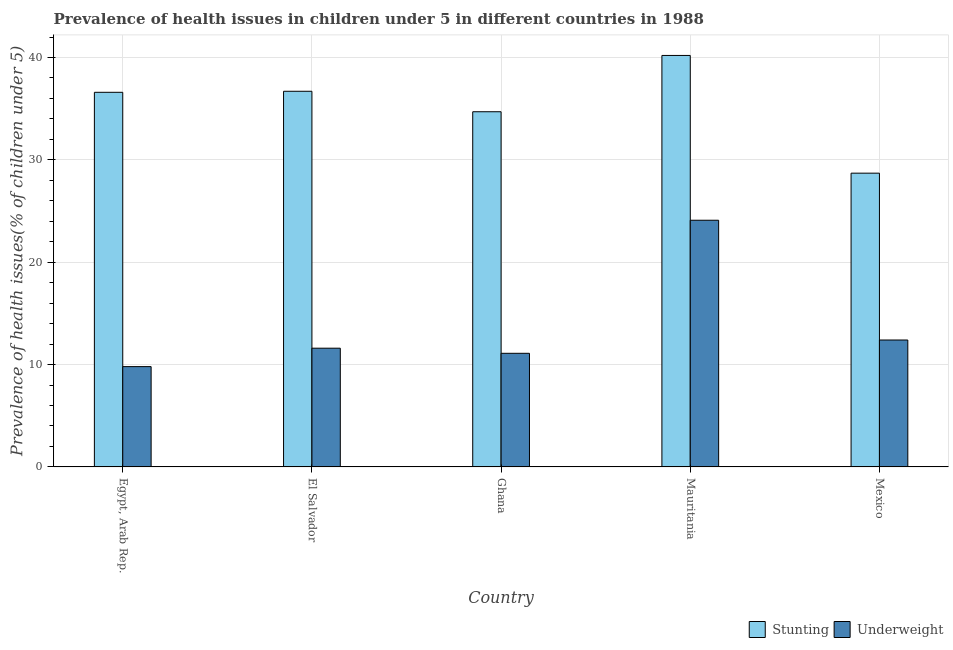How many different coloured bars are there?
Your answer should be very brief. 2. How many groups of bars are there?
Your answer should be very brief. 5. How many bars are there on the 1st tick from the right?
Offer a very short reply. 2. What is the percentage of stunted children in Mexico?
Keep it short and to the point. 28.7. Across all countries, what is the maximum percentage of underweight children?
Offer a terse response. 24.1. Across all countries, what is the minimum percentage of stunted children?
Make the answer very short. 28.7. In which country was the percentage of stunted children maximum?
Ensure brevity in your answer.  Mauritania. What is the total percentage of underweight children in the graph?
Your answer should be very brief. 69. What is the difference between the percentage of stunted children in El Salvador and that in Mauritania?
Your answer should be compact. -3.5. What is the difference between the percentage of underweight children in Mexico and the percentage of stunted children in Ghana?
Ensure brevity in your answer.  -22.3. What is the average percentage of underweight children per country?
Provide a succinct answer. 13.8. What is the difference between the percentage of underweight children and percentage of stunted children in Mexico?
Provide a succinct answer. -16.3. In how many countries, is the percentage of underweight children greater than 40 %?
Your answer should be very brief. 0. What is the ratio of the percentage of stunted children in Ghana to that in Mauritania?
Provide a succinct answer. 0.86. Is the difference between the percentage of stunted children in El Salvador and Ghana greater than the difference between the percentage of underweight children in El Salvador and Ghana?
Make the answer very short. Yes. What is the difference between the highest and the second highest percentage of stunted children?
Offer a terse response. 3.5. What is the difference between the highest and the lowest percentage of underweight children?
Your answer should be very brief. 14.3. In how many countries, is the percentage of underweight children greater than the average percentage of underweight children taken over all countries?
Make the answer very short. 1. Is the sum of the percentage of stunted children in Egypt, Arab Rep. and El Salvador greater than the maximum percentage of underweight children across all countries?
Offer a very short reply. Yes. What does the 2nd bar from the left in Egypt, Arab Rep. represents?
Offer a terse response. Underweight. What does the 2nd bar from the right in Ghana represents?
Your response must be concise. Stunting. How many bars are there?
Ensure brevity in your answer.  10. How many countries are there in the graph?
Give a very brief answer. 5. Are the values on the major ticks of Y-axis written in scientific E-notation?
Provide a short and direct response. No. Does the graph contain grids?
Provide a succinct answer. Yes. Where does the legend appear in the graph?
Ensure brevity in your answer.  Bottom right. How many legend labels are there?
Ensure brevity in your answer.  2. How are the legend labels stacked?
Provide a short and direct response. Horizontal. What is the title of the graph?
Offer a very short reply. Prevalence of health issues in children under 5 in different countries in 1988. What is the label or title of the Y-axis?
Provide a succinct answer. Prevalence of health issues(% of children under 5). What is the Prevalence of health issues(% of children under 5) in Stunting in Egypt, Arab Rep.?
Your answer should be very brief. 36.6. What is the Prevalence of health issues(% of children under 5) in Underweight in Egypt, Arab Rep.?
Offer a terse response. 9.8. What is the Prevalence of health issues(% of children under 5) of Stunting in El Salvador?
Your answer should be compact. 36.7. What is the Prevalence of health issues(% of children under 5) in Underweight in El Salvador?
Keep it short and to the point. 11.6. What is the Prevalence of health issues(% of children under 5) in Stunting in Ghana?
Offer a terse response. 34.7. What is the Prevalence of health issues(% of children under 5) in Underweight in Ghana?
Your response must be concise. 11.1. What is the Prevalence of health issues(% of children under 5) in Stunting in Mauritania?
Offer a terse response. 40.2. What is the Prevalence of health issues(% of children under 5) of Underweight in Mauritania?
Offer a terse response. 24.1. What is the Prevalence of health issues(% of children under 5) in Stunting in Mexico?
Offer a terse response. 28.7. What is the Prevalence of health issues(% of children under 5) in Underweight in Mexico?
Ensure brevity in your answer.  12.4. Across all countries, what is the maximum Prevalence of health issues(% of children under 5) of Stunting?
Give a very brief answer. 40.2. Across all countries, what is the maximum Prevalence of health issues(% of children under 5) of Underweight?
Ensure brevity in your answer.  24.1. Across all countries, what is the minimum Prevalence of health issues(% of children under 5) of Stunting?
Offer a terse response. 28.7. Across all countries, what is the minimum Prevalence of health issues(% of children under 5) in Underweight?
Give a very brief answer. 9.8. What is the total Prevalence of health issues(% of children under 5) in Stunting in the graph?
Keep it short and to the point. 176.9. What is the difference between the Prevalence of health issues(% of children under 5) of Underweight in Egypt, Arab Rep. and that in El Salvador?
Give a very brief answer. -1.8. What is the difference between the Prevalence of health issues(% of children under 5) in Stunting in Egypt, Arab Rep. and that in Ghana?
Your response must be concise. 1.9. What is the difference between the Prevalence of health issues(% of children under 5) in Underweight in Egypt, Arab Rep. and that in Ghana?
Provide a succinct answer. -1.3. What is the difference between the Prevalence of health issues(% of children under 5) of Stunting in Egypt, Arab Rep. and that in Mauritania?
Give a very brief answer. -3.6. What is the difference between the Prevalence of health issues(% of children under 5) of Underweight in Egypt, Arab Rep. and that in Mauritania?
Your answer should be very brief. -14.3. What is the difference between the Prevalence of health issues(% of children under 5) of Underweight in Egypt, Arab Rep. and that in Mexico?
Ensure brevity in your answer.  -2.6. What is the difference between the Prevalence of health issues(% of children under 5) in Underweight in El Salvador and that in Ghana?
Your answer should be very brief. 0.5. What is the difference between the Prevalence of health issues(% of children under 5) in Stunting in El Salvador and that in Mexico?
Ensure brevity in your answer.  8. What is the difference between the Prevalence of health issues(% of children under 5) of Stunting in Ghana and that in Mauritania?
Your answer should be very brief. -5.5. What is the difference between the Prevalence of health issues(% of children under 5) of Stunting in Ghana and that in Mexico?
Give a very brief answer. 6. What is the difference between the Prevalence of health issues(% of children under 5) in Stunting in Egypt, Arab Rep. and the Prevalence of health issues(% of children under 5) in Underweight in El Salvador?
Give a very brief answer. 25. What is the difference between the Prevalence of health issues(% of children under 5) of Stunting in Egypt, Arab Rep. and the Prevalence of health issues(% of children under 5) of Underweight in Ghana?
Provide a succinct answer. 25.5. What is the difference between the Prevalence of health issues(% of children under 5) in Stunting in Egypt, Arab Rep. and the Prevalence of health issues(% of children under 5) in Underweight in Mauritania?
Offer a terse response. 12.5. What is the difference between the Prevalence of health issues(% of children under 5) of Stunting in Egypt, Arab Rep. and the Prevalence of health issues(% of children under 5) of Underweight in Mexico?
Offer a very short reply. 24.2. What is the difference between the Prevalence of health issues(% of children under 5) of Stunting in El Salvador and the Prevalence of health issues(% of children under 5) of Underweight in Ghana?
Provide a succinct answer. 25.6. What is the difference between the Prevalence of health issues(% of children under 5) of Stunting in El Salvador and the Prevalence of health issues(% of children under 5) of Underweight in Mauritania?
Provide a short and direct response. 12.6. What is the difference between the Prevalence of health issues(% of children under 5) of Stunting in El Salvador and the Prevalence of health issues(% of children under 5) of Underweight in Mexico?
Offer a very short reply. 24.3. What is the difference between the Prevalence of health issues(% of children under 5) of Stunting in Ghana and the Prevalence of health issues(% of children under 5) of Underweight in Mauritania?
Offer a very short reply. 10.6. What is the difference between the Prevalence of health issues(% of children under 5) in Stunting in Ghana and the Prevalence of health issues(% of children under 5) in Underweight in Mexico?
Offer a terse response. 22.3. What is the difference between the Prevalence of health issues(% of children under 5) in Stunting in Mauritania and the Prevalence of health issues(% of children under 5) in Underweight in Mexico?
Give a very brief answer. 27.8. What is the average Prevalence of health issues(% of children under 5) in Stunting per country?
Give a very brief answer. 35.38. What is the average Prevalence of health issues(% of children under 5) in Underweight per country?
Provide a short and direct response. 13.8. What is the difference between the Prevalence of health issues(% of children under 5) in Stunting and Prevalence of health issues(% of children under 5) in Underweight in Egypt, Arab Rep.?
Your response must be concise. 26.8. What is the difference between the Prevalence of health issues(% of children under 5) of Stunting and Prevalence of health issues(% of children under 5) of Underweight in El Salvador?
Your response must be concise. 25.1. What is the difference between the Prevalence of health issues(% of children under 5) of Stunting and Prevalence of health issues(% of children under 5) of Underweight in Ghana?
Your answer should be compact. 23.6. What is the difference between the Prevalence of health issues(% of children under 5) in Stunting and Prevalence of health issues(% of children under 5) in Underweight in Mexico?
Give a very brief answer. 16.3. What is the ratio of the Prevalence of health issues(% of children under 5) of Stunting in Egypt, Arab Rep. to that in El Salvador?
Provide a succinct answer. 1. What is the ratio of the Prevalence of health issues(% of children under 5) in Underweight in Egypt, Arab Rep. to that in El Salvador?
Give a very brief answer. 0.84. What is the ratio of the Prevalence of health issues(% of children under 5) in Stunting in Egypt, Arab Rep. to that in Ghana?
Offer a very short reply. 1.05. What is the ratio of the Prevalence of health issues(% of children under 5) of Underweight in Egypt, Arab Rep. to that in Ghana?
Ensure brevity in your answer.  0.88. What is the ratio of the Prevalence of health issues(% of children under 5) in Stunting in Egypt, Arab Rep. to that in Mauritania?
Your answer should be compact. 0.91. What is the ratio of the Prevalence of health issues(% of children under 5) in Underweight in Egypt, Arab Rep. to that in Mauritania?
Ensure brevity in your answer.  0.41. What is the ratio of the Prevalence of health issues(% of children under 5) of Stunting in Egypt, Arab Rep. to that in Mexico?
Provide a short and direct response. 1.28. What is the ratio of the Prevalence of health issues(% of children under 5) in Underweight in Egypt, Arab Rep. to that in Mexico?
Ensure brevity in your answer.  0.79. What is the ratio of the Prevalence of health issues(% of children under 5) of Stunting in El Salvador to that in Ghana?
Your response must be concise. 1.06. What is the ratio of the Prevalence of health issues(% of children under 5) in Underweight in El Salvador to that in Ghana?
Provide a succinct answer. 1.04. What is the ratio of the Prevalence of health issues(% of children under 5) of Stunting in El Salvador to that in Mauritania?
Make the answer very short. 0.91. What is the ratio of the Prevalence of health issues(% of children under 5) in Underweight in El Salvador to that in Mauritania?
Your answer should be compact. 0.48. What is the ratio of the Prevalence of health issues(% of children under 5) of Stunting in El Salvador to that in Mexico?
Keep it short and to the point. 1.28. What is the ratio of the Prevalence of health issues(% of children under 5) of Underweight in El Salvador to that in Mexico?
Your answer should be compact. 0.94. What is the ratio of the Prevalence of health issues(% of children under 5) of Stunting in Ghana to that in Mauritania?
Offer a very short reply. 0.86. What is the ratio of the Prevalence of health issues(% of children under 5) of Underweight in Ghana to that in Mauritania?
Ensure brevity in your answer.  0.46. What is the ratio of the Prevalence of health issues(% of children under 5) in Stunting in Ghana to that in Mexico?
Make the answer very short. 1.21. What is the ratio of the Prevalence of health issues(% of children under 5) of Underweight in Ghana to that in Mexico?
Offer a terse response. 0.9. What is the ratio of the Prevalence of health issues(% of children under 5) of Stunting in Mauritania to that in Mexico?
Keep it short and to the point. 1.4. What is the ratio of the Prevalence of health issues(% of children under 5) in Underweight in Mauritania to that in Mexico?
Keep it short and to the point. 1.94. What is the difference between the highest and the second highest Prevalence of health issues(% of children under 5) in Stunting?
Give a very brief answer. 3.5. What is the difference between the highest and the second highest Prevalence of health issues(% of children under 5) of Underweight?
Make the answer very short. 11.7. What is the difference between the highest and the lowest Prevalence of health issues(% of children under 5) of Stunting?
Your answer should be compact. 11.5. What is the difference between the highest and the lowest Prevalence of health issues(% of children under 5) in Underweight?
Ensure brevity in your answer.  14.3. 